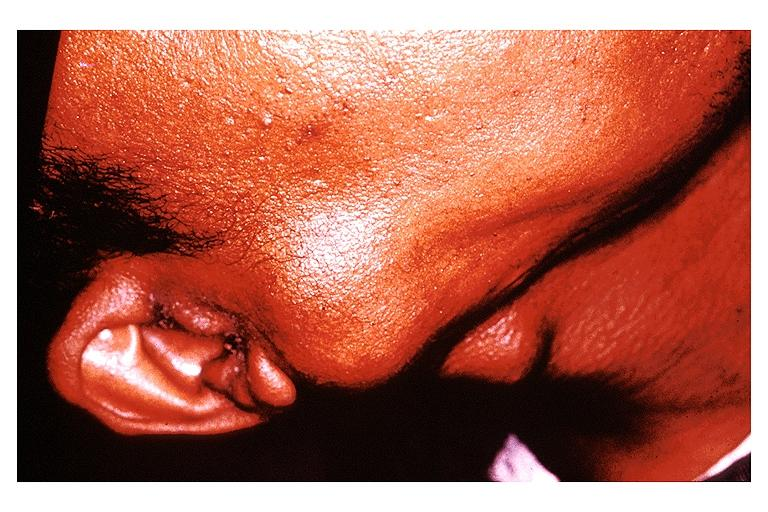does this image show pleomorphic adenoma benign mixed tumor?
Answer the question using a single word or phrase. Yes 